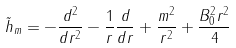<formula> <loc_0><loc_0><loc_500><loc_500>\tilde { h } _ { m } = - \frac { d ^ { 2 } } { d r ^ { 2 } } - \frac { 1 } { r } \frac { d } { d r } + \frac { m ^ { 2 } } { r ^ { 2 } } + \frac { B _ { 0 } ^ { 2 } r ^ { 2 } } { 4 }</formula> 